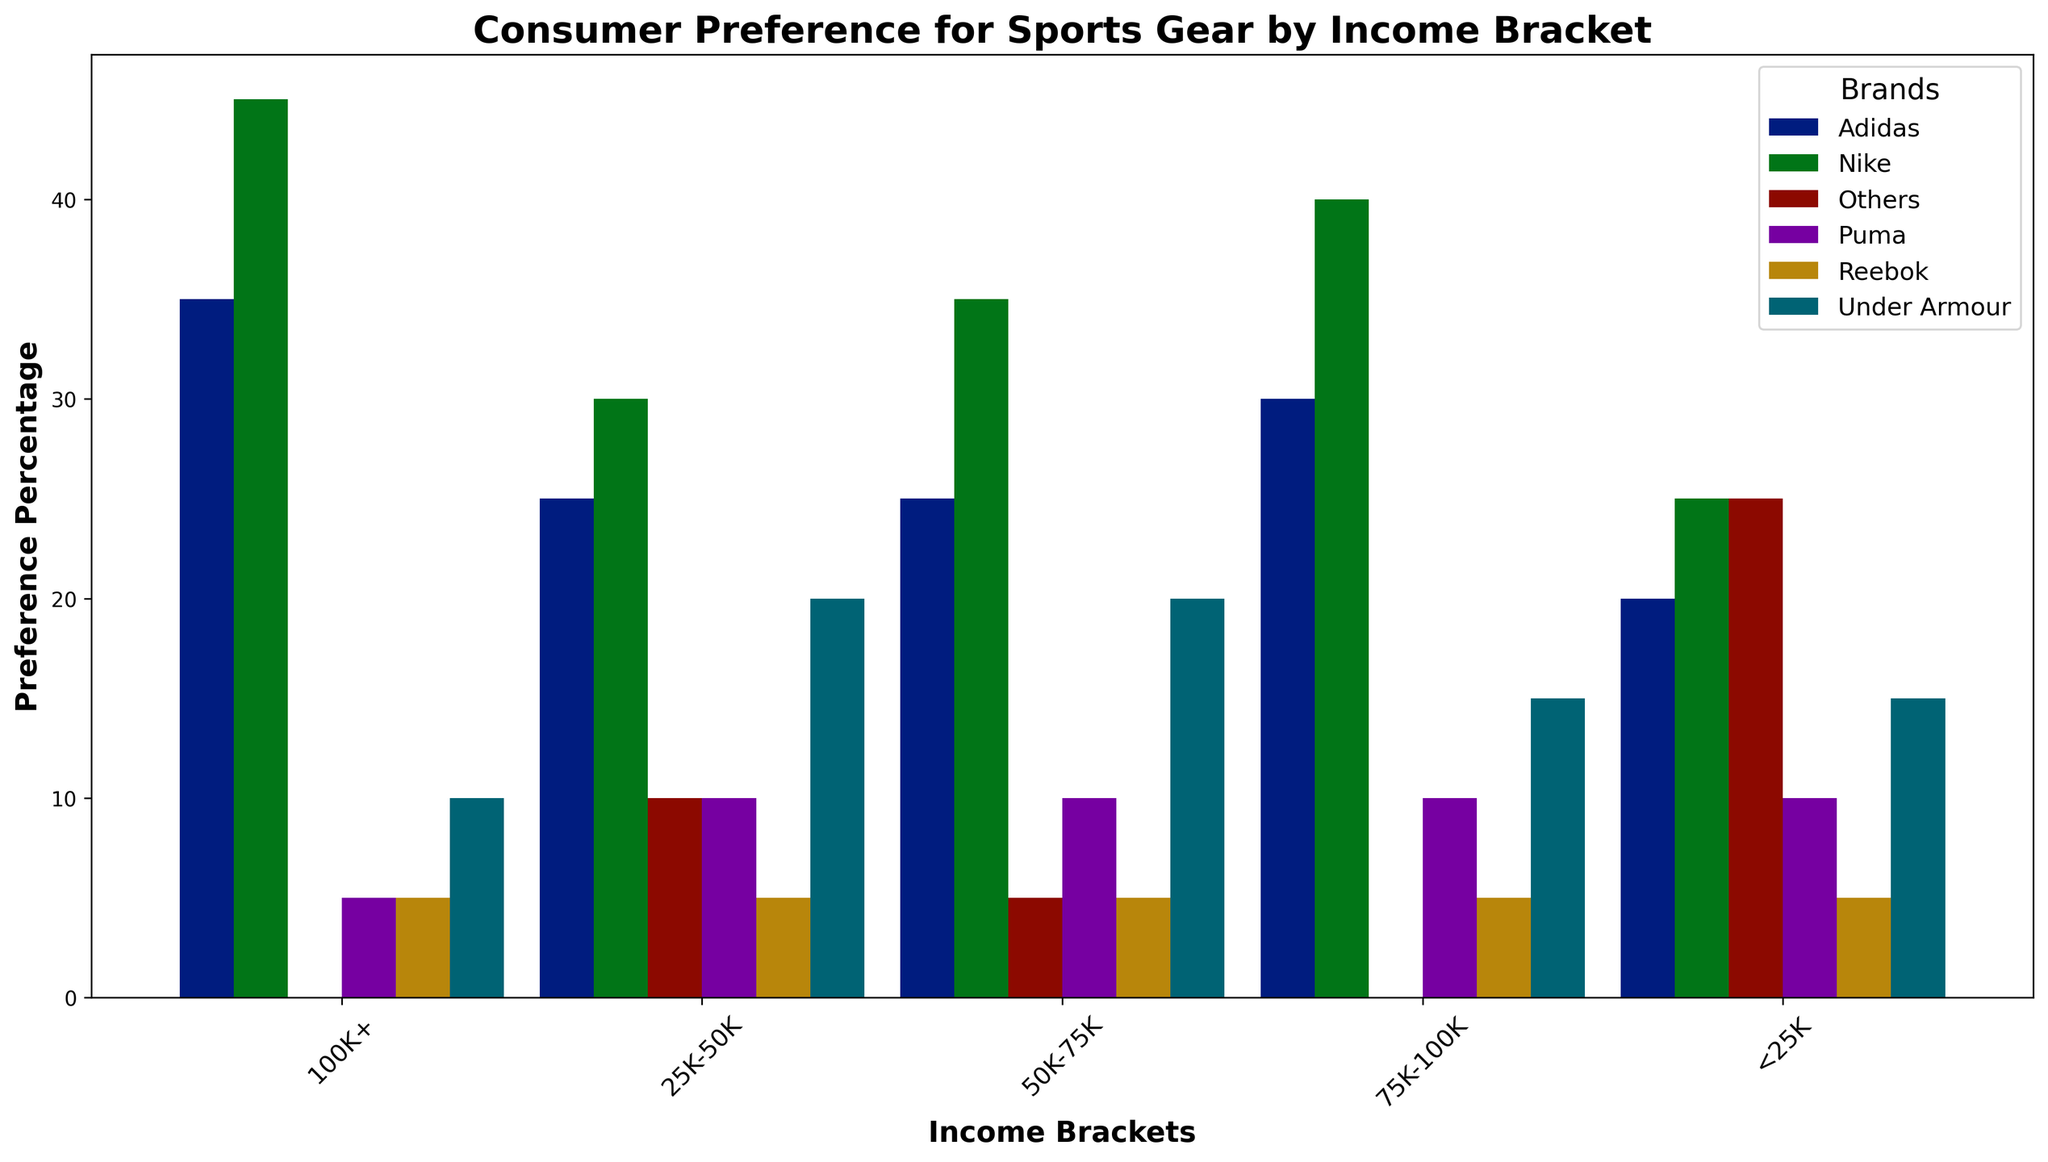What is the most preferred brand among consumers in the 50K-75K income bracket? Look at the bars for the 50K-75K income bracket and identify the tallest one, which represents the most preferred brand. The tallest bar belongs to Nike.
Answer: Nike Which income bracket shows the highest preference for Adidas? Compare the heights of the bars representing Adidas across all income brackets. The tallest bar is in the 100K+ income bracket.
Answer: 100K+ How does the preference percentage for Reebok compare between the <25K and 100K+ income brackets? Check the heights of the bars for Reebok in both the <25K and 100K+ income brackets. Both bars are at the same height, representing 5%.
Answer: Equal What is the combined preference percentage for Under Armour across all income brackets? Sum the percentages for Under Armour across all income brackets: 15% ( <25K) + 20% (25K-50K) + 20% (50K-75K) + 15% (75K-100K) + 10% (100K+). The total is 80%.
Answer: 80% Which income bracket has the lowest combined preference percentage for Nike and Adidas? Sum the preference percentages of Nike and Adidas for each income bracket and identify the lowest: 
(25% + 20%) <25K = 45% 
(30% + 25%) 25K-50K = 55% 
(35% + 25%) 50K-75K = 60% 
(40% + 30%) 75K-100K = 70% 
(45% + 35%) 100K+ = 80%. The lowest sum is for <25K, 45%.
Answer: <25K Which brand has the most consistent preference percentage across different income brackets? Observe the bars for each brand across all income brackets and see which brand has the least variation in heights. Reebok has a consistent 5% in all but one income bracket.
Answer: Reebok In the 25K-50K income bracket, how does the preference for Puma compare to the preference for Under Armour? Look at the heights of the bars for Puma and Under Armour in the 25K-50K income bracket. Under Armour has a higher bar (20%) than Puma (10%).
Answer: Under Armour is higher What is the difference in preference percentage for Nike between the <25K and 100K+ income brackets? Subtract the preference percentage of Nike in the <25K bracket (25%) from that in the 100K+ bracket (45%). The difference is 45% - 25% = 20%.
Answer: 20% What is the combined preference percentage for the "Others" category across all income brackets? Sum the percentages for "Others" across all income brackets: 25% ( <25K) + 10% (25K-50K) + 5% (50K-75K) + 0% (75K-100K) + 0% (100K+). The total is 40%.
Answer: 40% In which income bracket is Puma's preference percentage the highest? Compare the heights of the bars representing Puma across all income brackets. The highest bar is in all income brackets with 10%.
Answer: All at 10% 